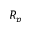Convert formula to latex. <formula><loc_0><loc_0><loc_500><loc_500>R _ { p }</formula> 